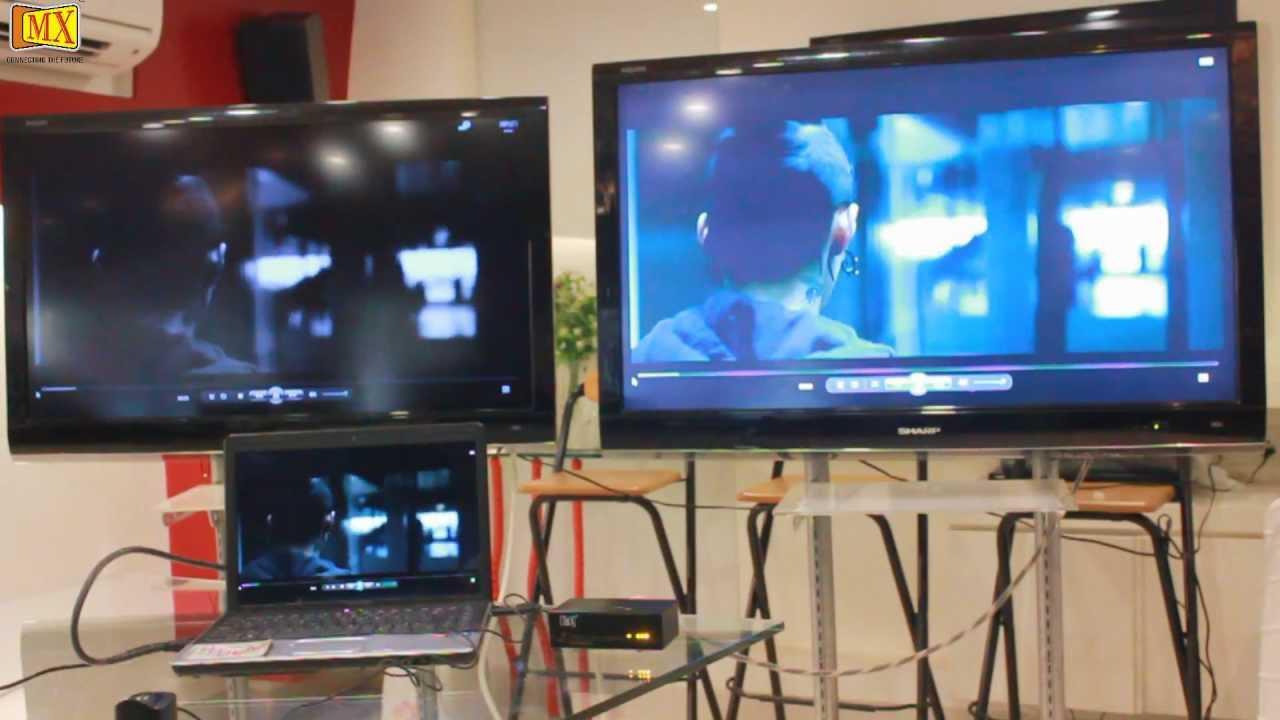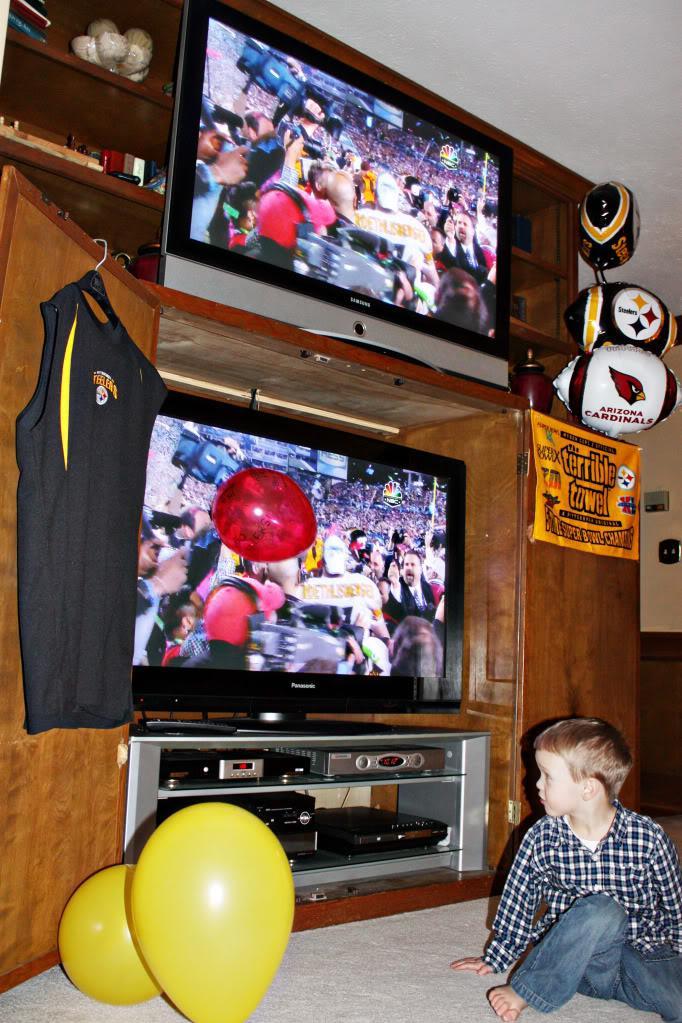The first image is the image on the left, the second image is the image on the right. Given the left and right images, does the statement "Two screens sit side by side in the image on the left." hold true? Answer yes or no. Yes. 